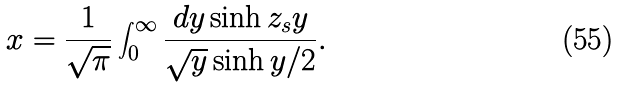<formula> <loc_0><loc_0><loc_500><loc_500>x = \frac { 1 } { \sqrt { \pi } } \int _ { 0 } ^ { \infty } \frac { d y \sinh { z _ { s } y } } { \sqrt { y } \sinh { y / 2 } } .</formula> 